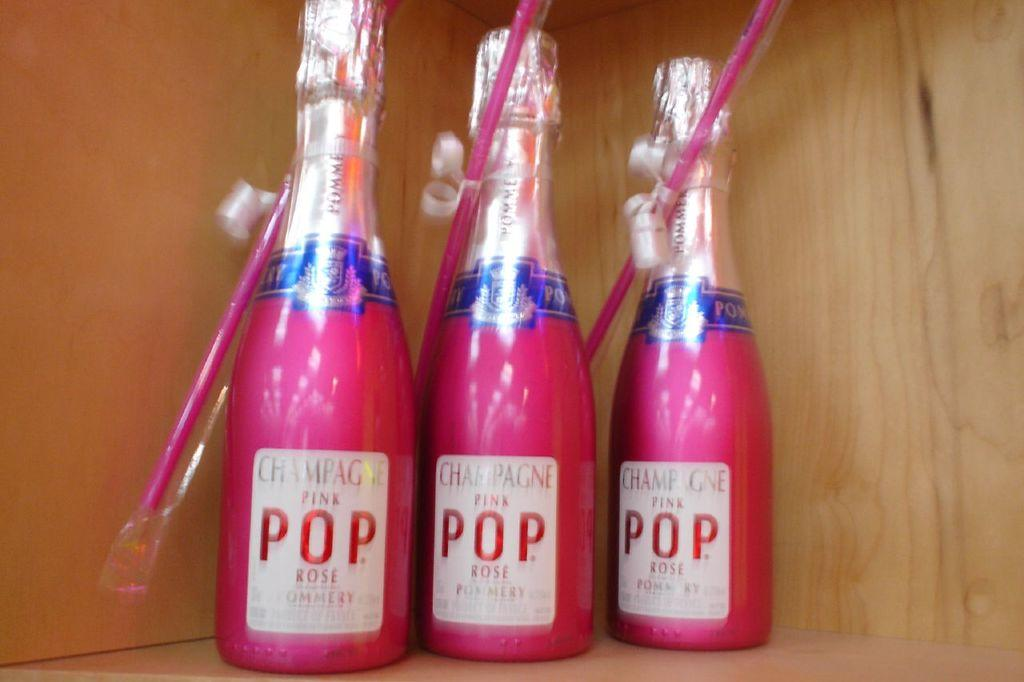<image>
Summarize the visual content of the image. Three bottles of pink Champagne Pop are being displayed with straws attached. 